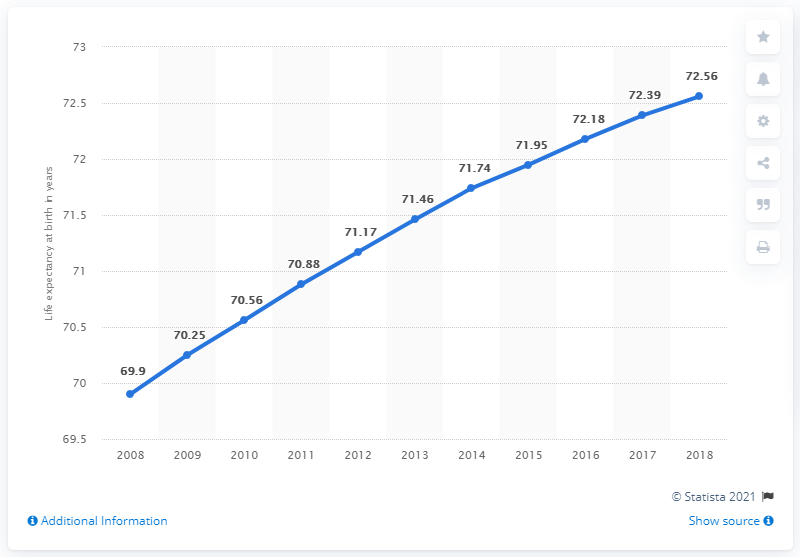Point out several critical features in this image. The average value of the data points from 2016 to 2018 is 72.38. In the year 2021, the median life expectancy was 71.46 years. 